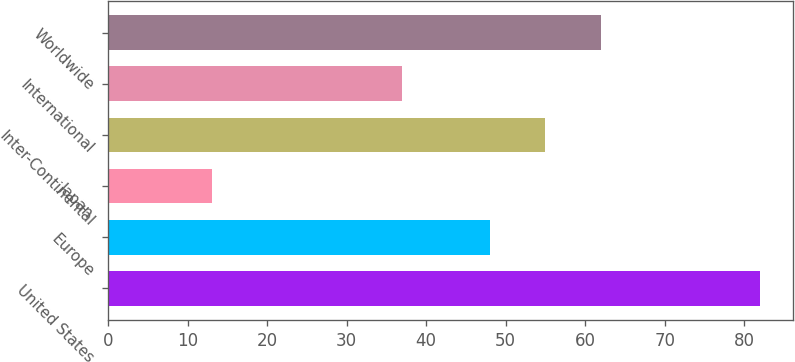<chart> <loc_0><loc_0><loc_500><loc_500><bar_chart><fcel>United States<fcel>Europe<fcel>Japan<fcel>Inter-Continental<fcel>International<fcel>Worldwide<nl><fcel>82<fcel>48<fcel>13<fcel>54.9<fcel>37<fcel>62<nl></chart> 